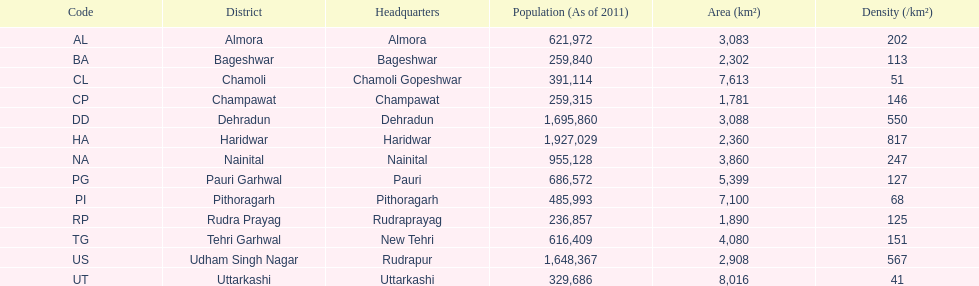Tell me the number of districts with an area over 5000. 4. 